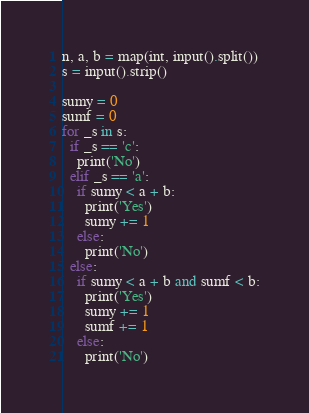<code> <loc_0><loc_0><loc_500><loc_500><_Python_>n, a, b = map(int, input().split())
s = input().strip()

sumy = 0
sumf = 0
for _s in s:
  if _s == 'c':
    print('No')
  elif _s == 'a':
    if sumy < a + b:
      print('Yes')
      sumy += 1
    else:
      print('No')
  else:
    if sumy < a + b and sumf < b:
      print('Yes')
      sumy += 1
      sumf += 1
    else:
      print('No')
</code> 